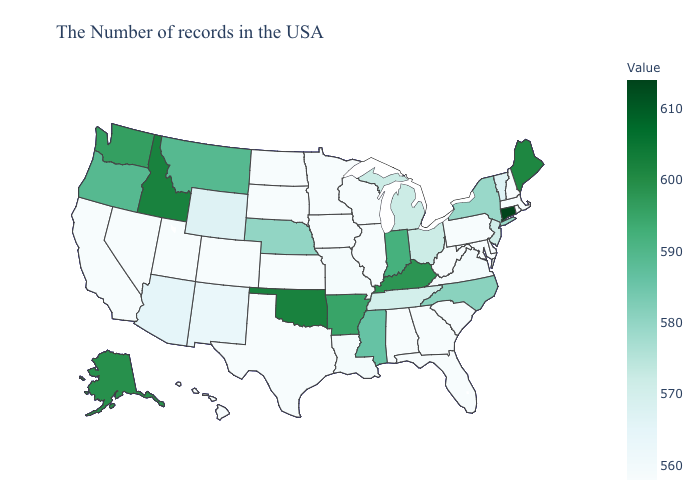Does Hawaii have a higher value than Arizona?
Answer briefly. No. Which states have the lowest value in the USA?
Be succinct. Massachusetts, Rhode Island, New Hampshire, Delaware, Maryland, Pennsylvania, South Carolina, West Virginia, Florida, Georgia, Alabama, Wisconsin, Illinois, Minnesota, Iowa, Kansas, Texas, South Dakota, North Dakota, Colorado, Utah, Nevada, California, Hawaii. 